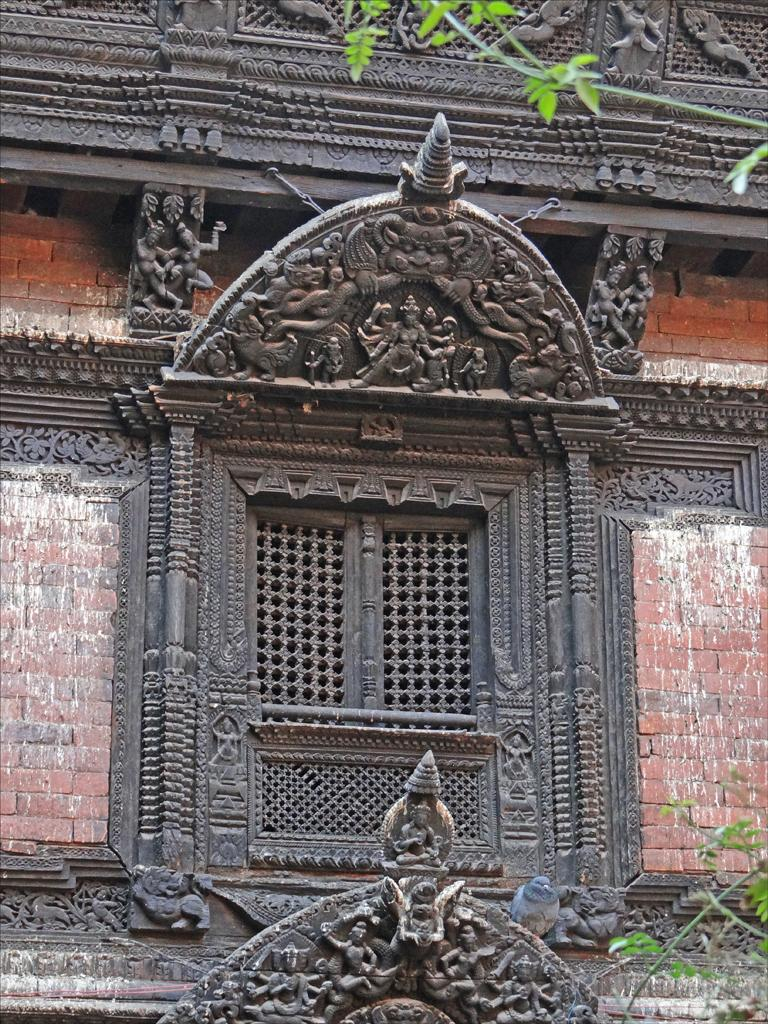What is depicted on the wall in the image? There is a wall with sculptures in the image. Can you describe any living creatures visible in the image? Yes, there is a bird visible in the image. Where are the leaves located in the image? The leaves are present in the bottom right and top right corners of the image. What type of selection process is being conducted by the cat in the image? There is no cat present in the image, so no selection process can be observed. What territory is being claimed by the bird in the image? The image does not depict any territorial claims by the bird; it is simply visible in the image. 